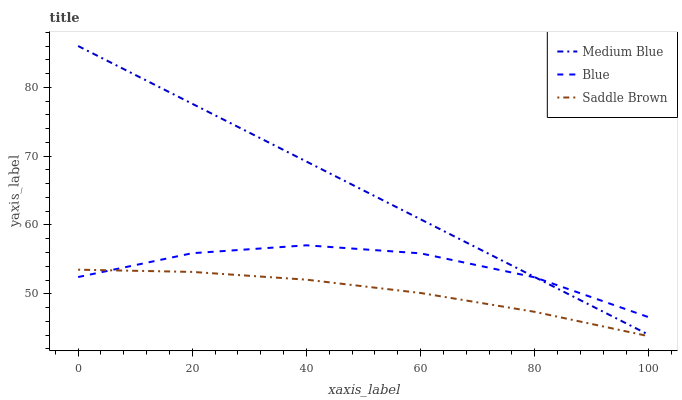Does Saddle Brown have the minimum area under the curve?
Answer yes or no. Yes. Does Medium Blue have the maximum area under the curve?
Answer yes or no. Yes. Does Medium Blue have the minimum area under the curve?
Answer yes or no. No. Does Saddle Brown have the maximum area under the curve?
Answer yes or no. No. Is Medium Blue the smoothest?
Answer yes or no. Yes. Is Blue the roughest?
Answer yes or no. Yes. Is Saddle Brown the smoothest?
Answer yes or no. No. Is Saddle Brown the roughest?
Answer yes or no. No. Does Medium Blue have the lowest value?
Answer yes or no. No. Does Medium Blue have the highest value?
Answer yes or no. Yes. Does Saddle Brown have the highest value?
Answer yes or no. No. Is Saddle Brown less than Medium Blue?
Answer yes or no. Yes. Is Medium Blue greater than Saddle Brown?
Answer yes or no. Yes. Does Blue intersect Saddle Brown?
Answer yes or no. Yes. Is Blue less than Saddle Brown?
Answer yes or no. No. Is Blue greater than Saddle Brown?
Answer yes or no. No. Does Saddle Brown intersect Medium Blue?
Answer yes or no. No. 